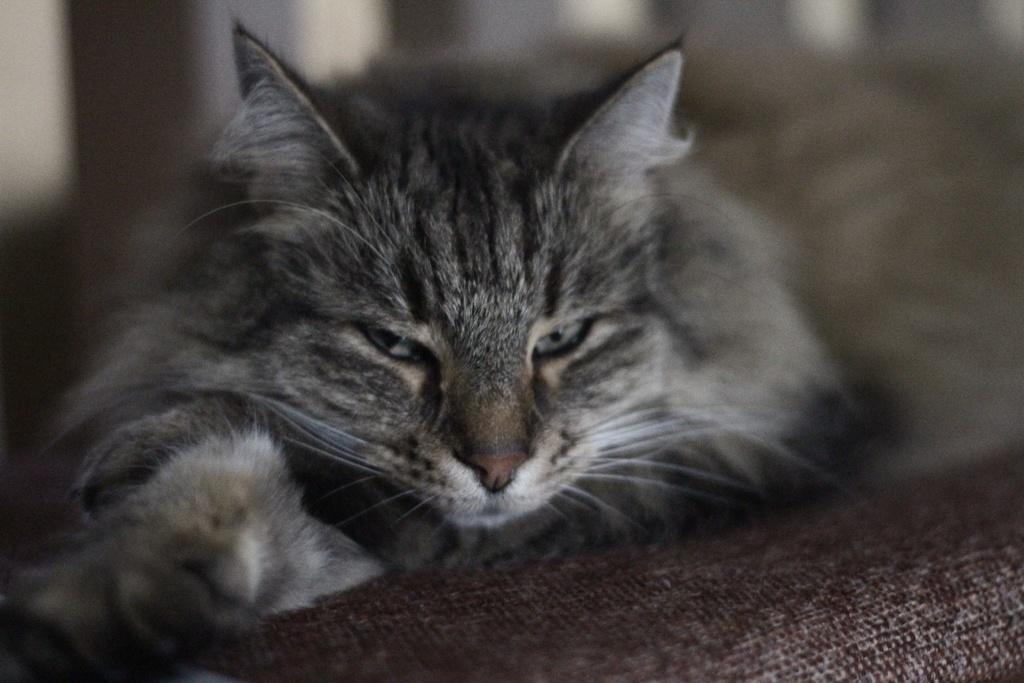In one or two sentences, can you explain what this image depicts? In this picture, we see a cat. It is looking at the camera. At the bottom, we see a carpet or a blanket. In the background, it is white in color and this picture is blurred in the background. 